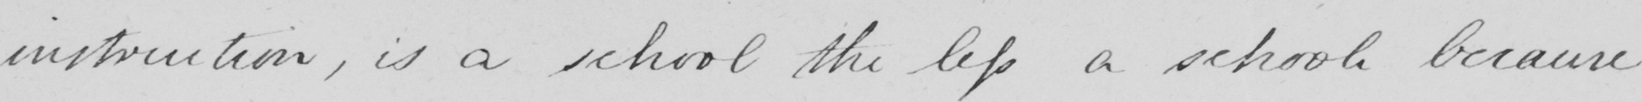Transcribe the text shown in this historical manuscript line. instruction , is a school the less a school because 